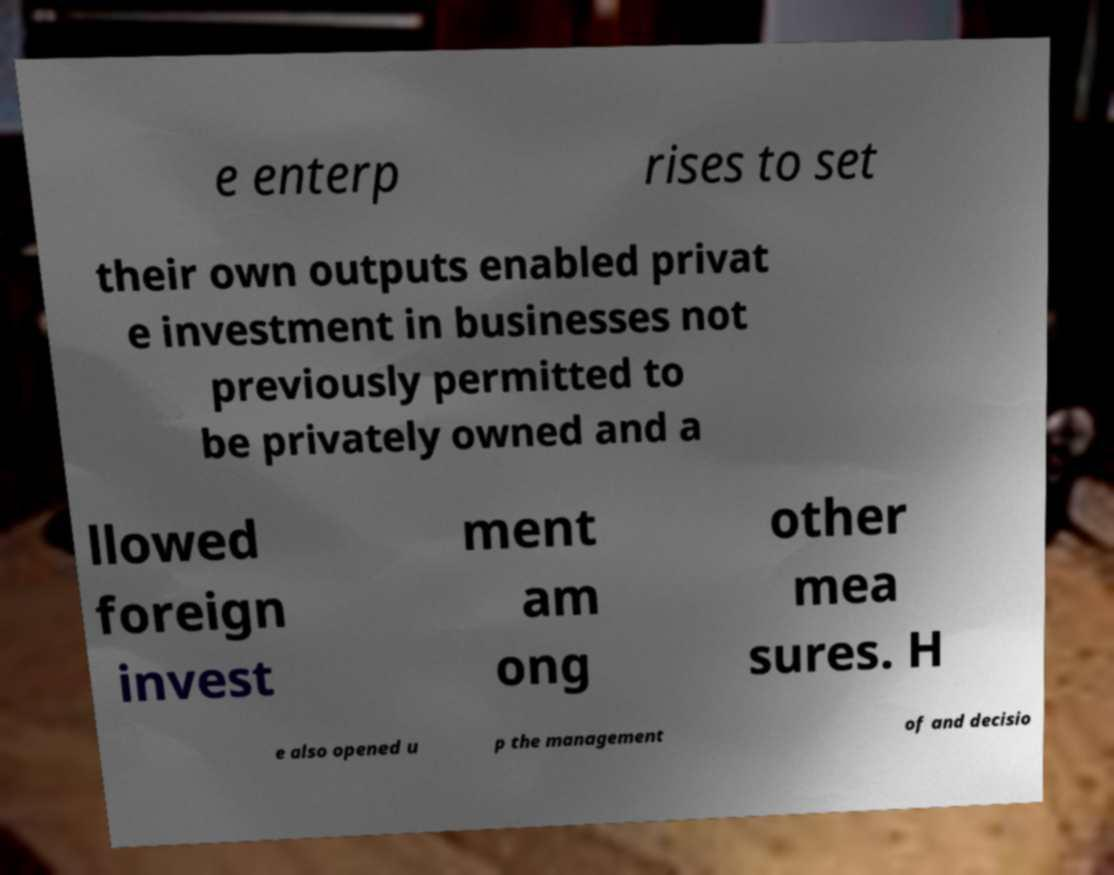Could you assist in decoding the text presented in this image and type it out clearly? e enterp rises to set their own outputs enabled privat e investment in businesses not previously permitted to be privately owned and a llowed foreign invest ment am ong other mea sures. H e also opened u p the management of and decisio 